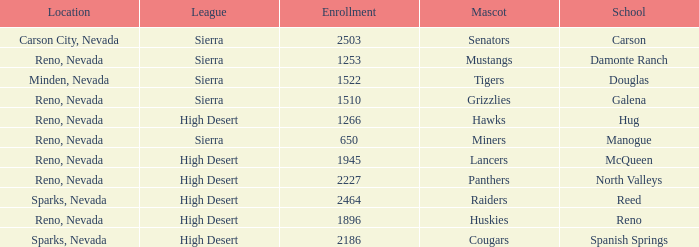What city and state is the Lancers mascot located? Reno, Nevada. 